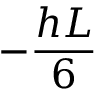<formula> <loc_0><loc_0><loc_500><loc_500>- \frac { h L } { 6 }</formula> 